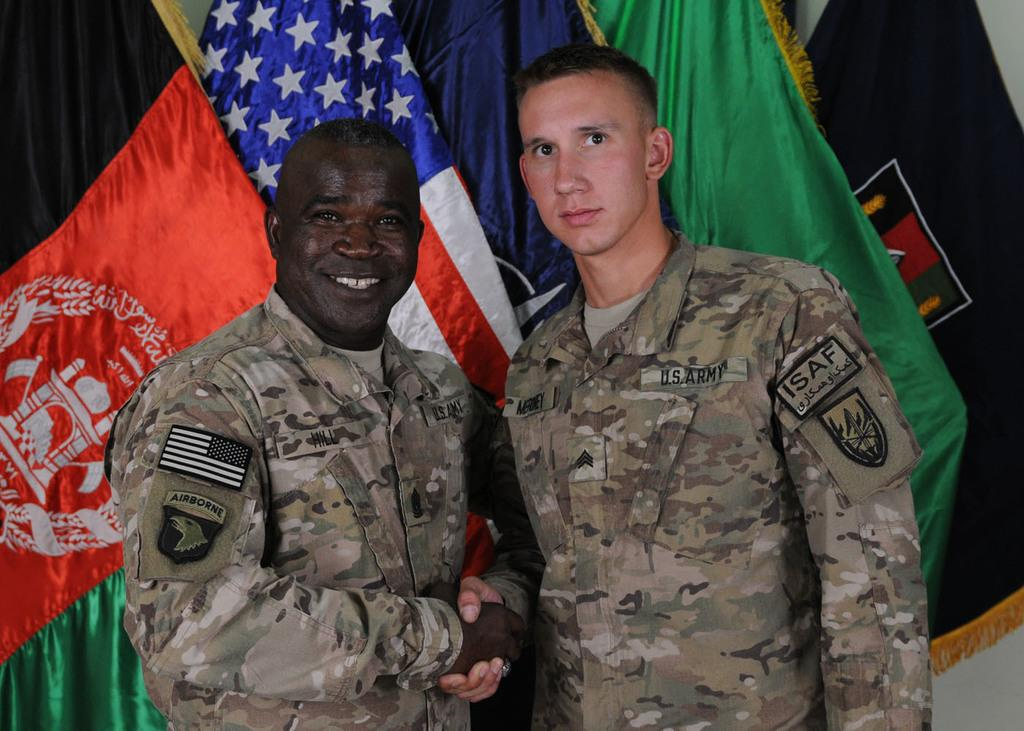How many people are present in the image? There are two people standing in the image. What can be seen in the background of the image? There are flags visible in the background of the image. What is the reaction of the people to the time in the image? There is no indication of the time or the people's reaction to it in the image. 